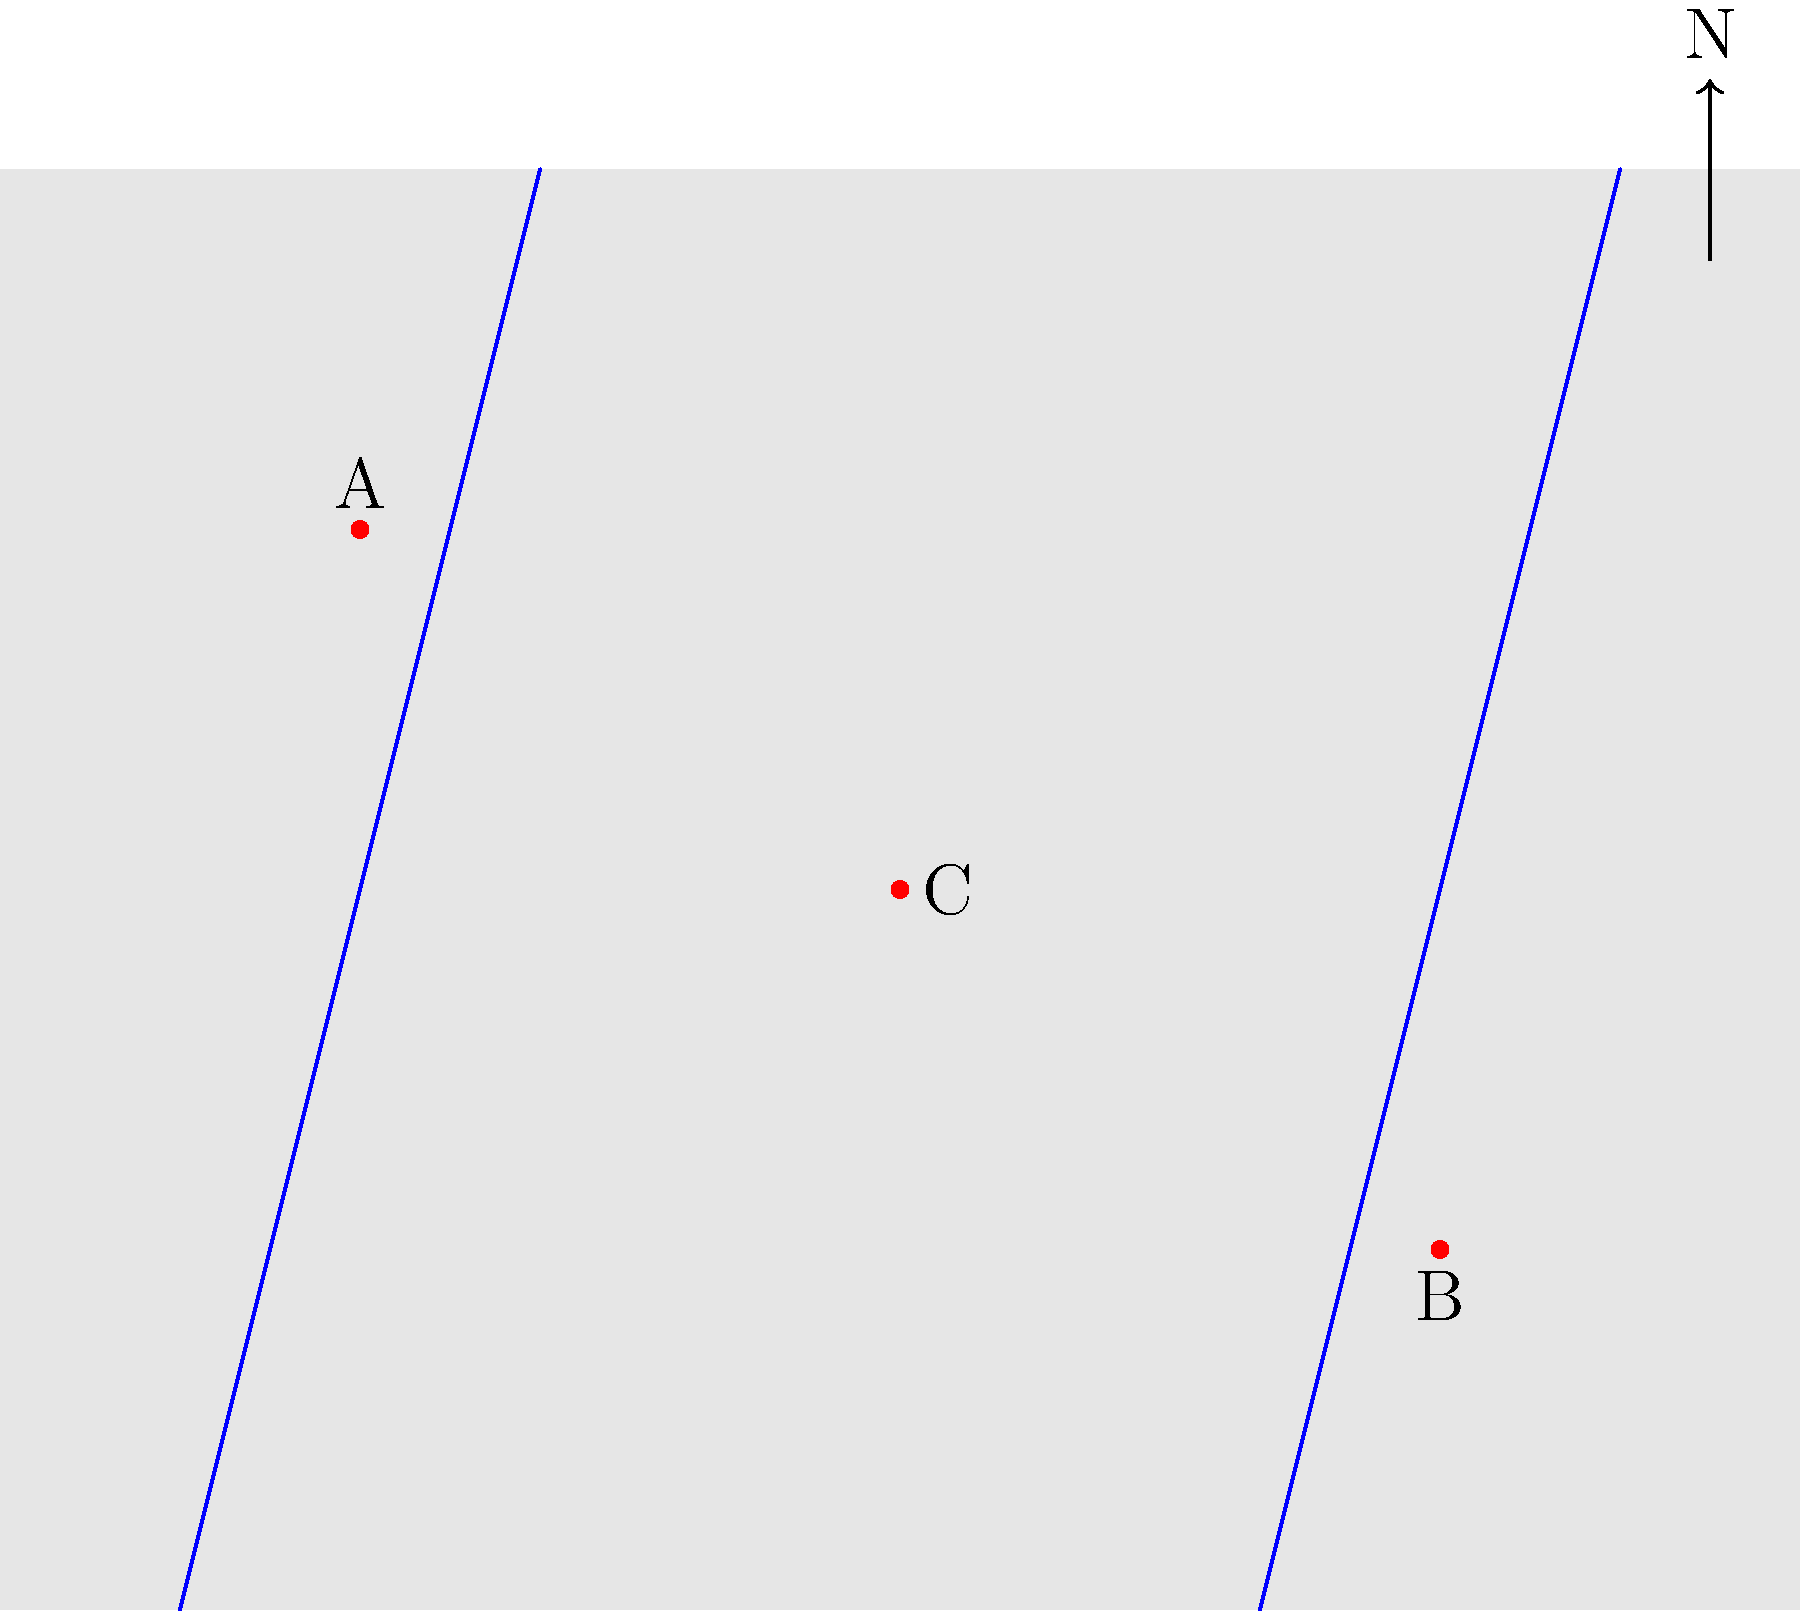On this simplified map of Iowa, which historical landmark is most likely represented by point C? To answer this question, we need to analyze the map and consider Iowa's geography and history:

1. The map shows a simplified outline of Iowa with three marked points (A, B, and C) and two rivers.

2. Point A is in the northeast, likely representing Dubuque, one of Iowa's oldest cities.

3. Point B is in the southwest, possibly representing Council Bluffs, an important city in Iowa's westward expansion history.

4. Point C is centrally located, which is crucial for identifying it as a historical landmark.

5. The two blue lines likely represent the Mississippi River (east) and the Missouri River (west).

6. Given its central location and historical significance, point C is most likely representing Des Moines, the state capital.

7. Des Moines has been Iowa's capital since 1857 and is home to important historical landmarks such as the Iowa State Capitol building.

8. Its central location made it an ideal choice for the capital, as it was accessible from all parts of the state.

Therefore, the historical landmark most likely represented by point C is the Iowa State Capitol in Des Moines.
Answer: Iowa State Capitol 